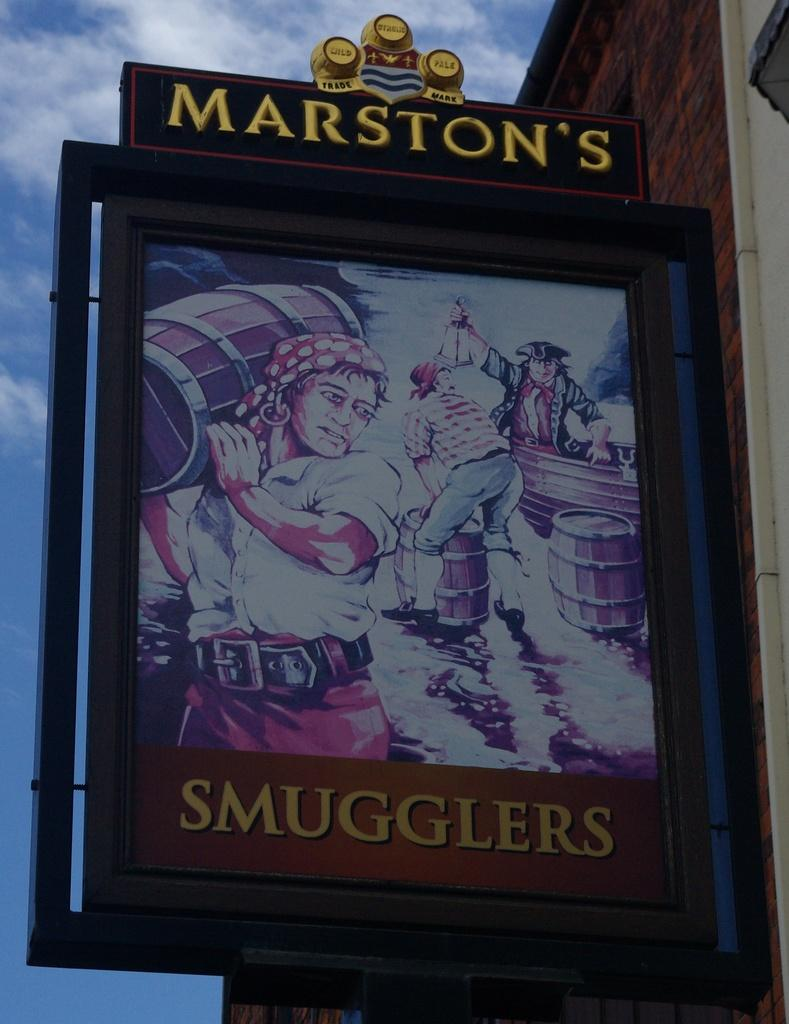What is the main subject in the center of the image? There is a board with text and cartoon images in the center of the image. Where is the board located? The board is on the wall of a building. Which side of the image does the building appear on? The building is on the right side of the image. How would you describe the sky in the image? The sky is cloudy in the image. What type of silk is used to create the notebook in the image? There is no notebook or silk present in the image. What additional details can be observed about the cartoon images on the board? The provided facts do not mention any additional details about the cartoon images on the board. 